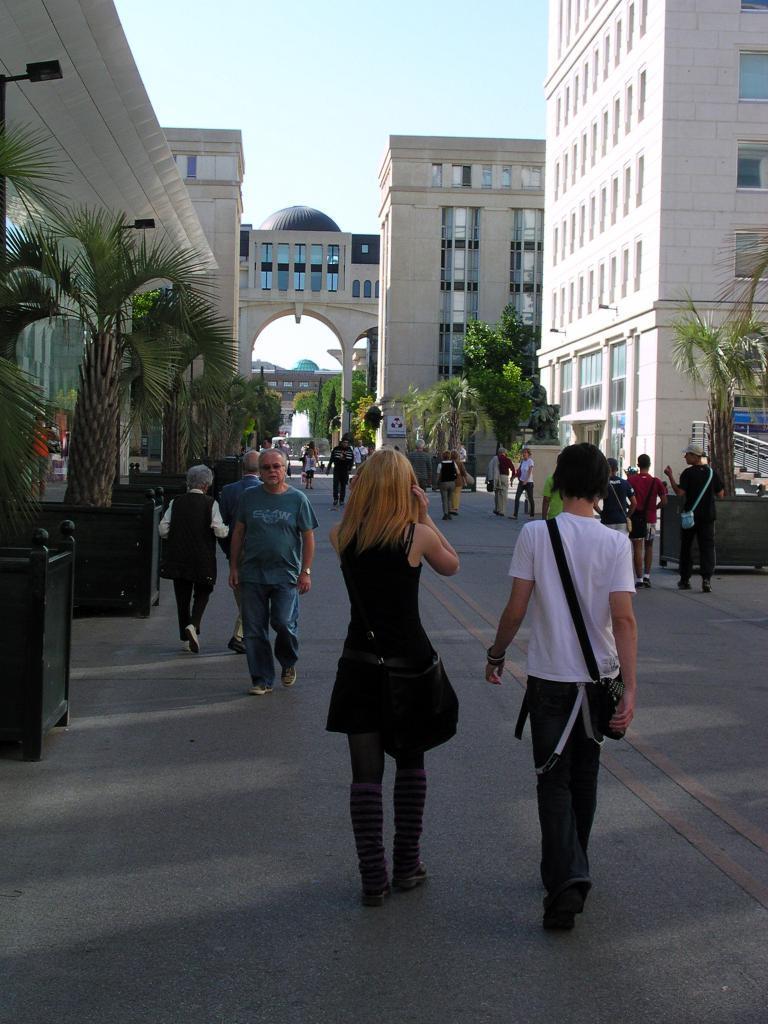Can you describe this image briefly? In this picture we can see a few people on the path. There are some plants visible on both sides of the path. There are a few black objects visible on the path. We can see a few arches on the wall. There is a poster visible on a building. We can see some buildings in the background. There is the sky on top of the picture. 